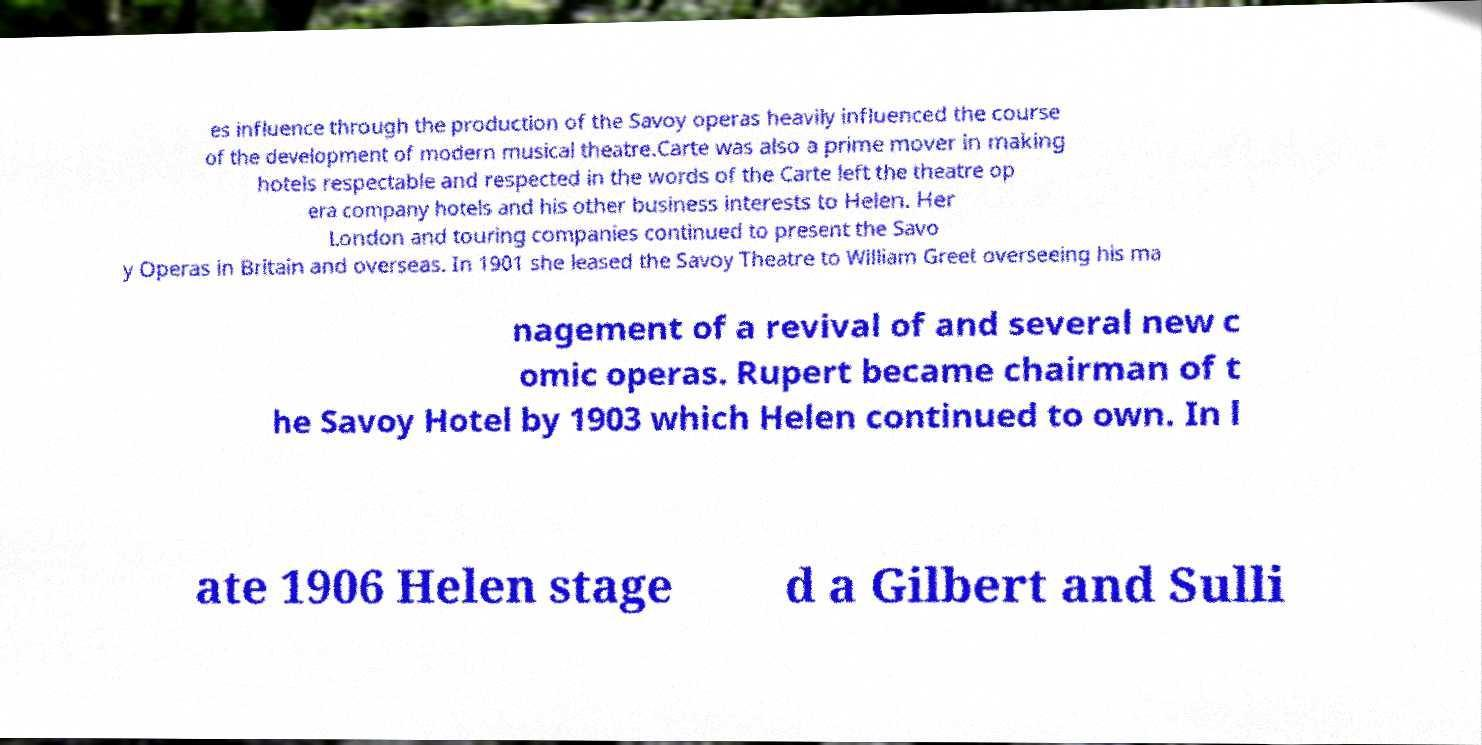Please identify and transcribe the text found in this image. es influence through the production of the Savoy operas heavily influenced the course of the development of modern musical theatre.Carte was also a prime mover in making hotels respectable and respected in the words of the Carte left the theatre op era company hotels and his other business interests to Helen. Her London and touring companies continued to present the Savo y Operas in Britain and overseas. In 1901 she leased the Savoy Theatre to William Greet overseeing his ma nagement of a revival of and several new c omic operas. Rupert became chairman of t he Savoy Hotel by 1903 which Helen continued to own. In l ate 1906 Helen stage d a Gilbert and Sulli 